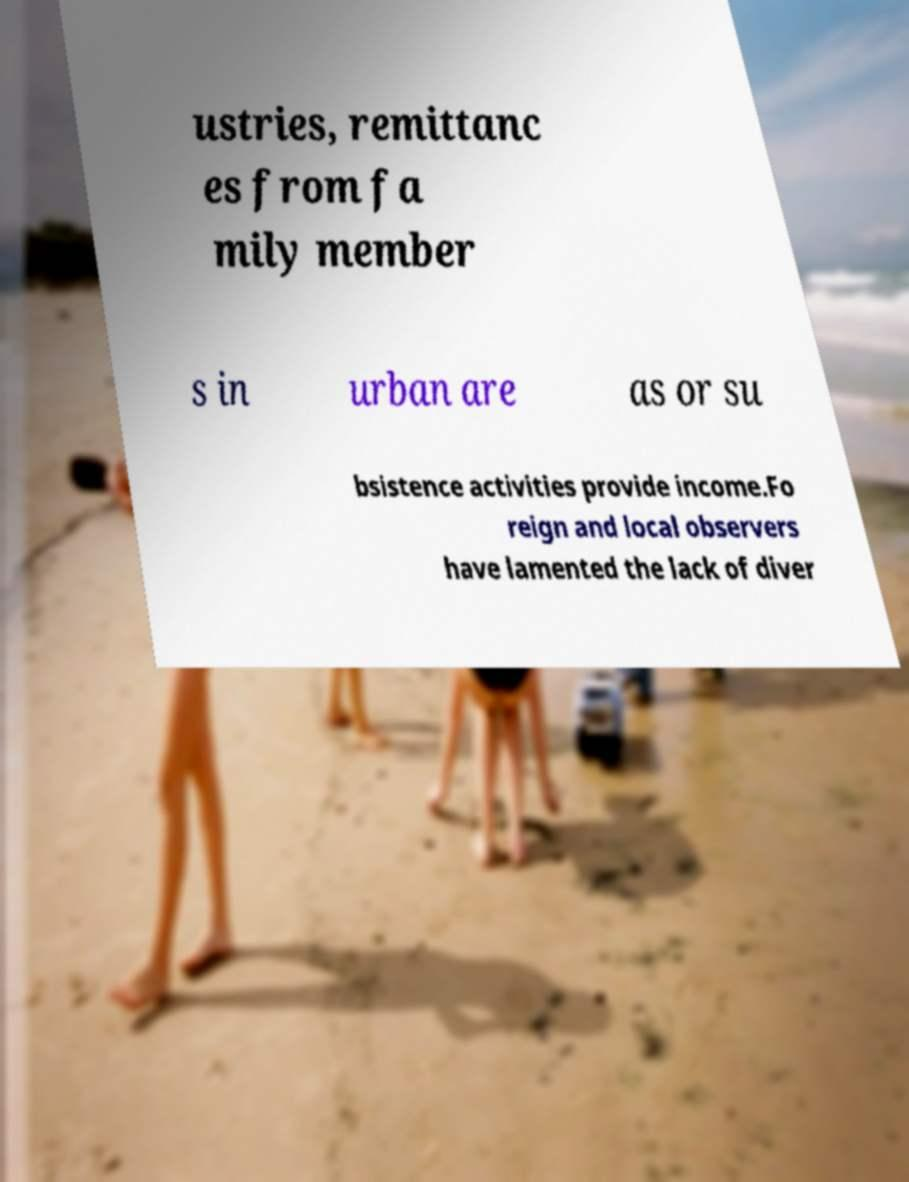What messages or text are displayed in this image? I need them in a readable, typed format. ustries, remittanc es from fa mily member s in urban are as or su bsistence activities provide income.Fo reign and local observers have lamented the lack of diver 